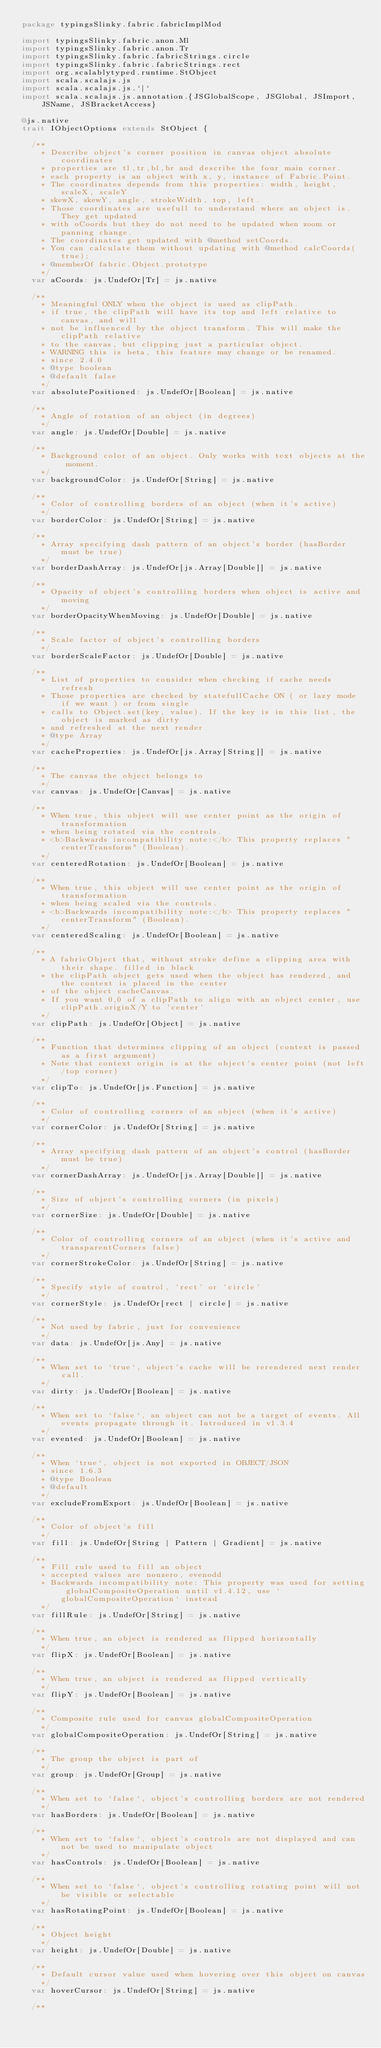Convert code to text. <code><loc_0><loc_0><loc_500><loc_500><_Scala_>package typingsSlinky.fabric.fabricImplMod

import typingsSlinky.fabric.anon.Ml
import typingsSlinky.fabric.anon.Tr
import typingsSlinky.fabric.fabricStrings.circle
import typingsSlinky.fabric.fabricStrings.rect
import org.scalablytyped.runtime.StObject
import scala.scalajs.js
import scala.scalajs.js.`|`
import scala.scalajs.js.annotation.{JSGlobalScope, JSGlobal, JSImport, JSName, JSBracketAccess}

@js.native
trait IObjectOptions extends StObject {
  
  /**
    * Describe object's corner position in canvas object absolute coordinates
    * properties are tl,tr,bl,br and describe the four main corner.
    * each property is an object with x, y, instance of Fabric.Point.
    * The coordinates depends from this properties: width, height, scaleX, scaleY
    * skewX, skewY, angle, strokeWidth, top, left.
    * Those coordinates are usefull to understand where an object is. They get updated
    * with oCoords but they do not need to be updated when zoom or panning change.
    * The coordinates get updated with @method setCoords.
    * You can calculate them without updating with @method calcCoords(true);
    * @memberOf fabric.Object.prototype
    */
  var aCoords: js.UndefOr[Tr] = js.native
  
  /**
    * Meaningful ONLY when the object is used as clipPath.
    * if true, the clipPath will have its top and left relative to canvas, and will
    * not be influenced by the object transform. This will make the clipPath relative
    * to the canvas, but clipping just a particular object.
    * WARNING this is beta, this feature may change or be renamed.
    * since 2.4.0
    * @type boolean
    * @default false
    */
  var absolutePositioned: js.UndefOr[Boolean] = js.native
  
  /**
    * Angle of rotation of an object (in degrees)
    */
  var angle: js.UndefOr[Double] = js.native
  
  /**
    * Background color of an object. Only works with text objects at the moment.
    */
  var backgroundColor: js.UndefOr[String] = js.native
  
  /**
    * Color of controlling borders of an object (when it's active)
    */
  var borderColor: js.UndefOr[String] = js.native
  
  /**
    * Array specifying dash pattern of an object's border (hasBorder must be true)
    */
  var borderDashArray: js.UndefOr[js.Array[Double]] = js.native
  
  /**
    * Opacity of object's controlling borders when object is active and moving
    */
  var borderOpacityWhenMoving: js.UndefOr[Double] = js.native
  
  /**
    * Scale factor of object's controlling borders
    */
  var borderScaleFactor: js.UndefOr[Double] = js.native
  
  /**
    * List of properties to consider when checking if cache needs refresh
    * Those properties are checked by statefullCache ON ( or lazy mode if we want ) or from single
    * calls to Object.set(key, value). If the key is in this list, the object is marked as dirty
    * and refreshed at the next render
    * @type Array
    */
  var cacheProperties: js.UndefOr[js.Array[String]] = js.native
  
  /**
    * The canvas the object belongs to
    */
  var canvas: js.UndefOr[Canvas] = js.native
  
  /**
    * When true, this object will use center point as the origin of transformation
    * when being rotated via the controls.
    * <b>Backwards incompatibility note:</b> This property replaces "centerTransform" (Boolean).
    */
  var centeredRotation: js.UndefOr[Boolean] = js.native
  
  /**
    * When true, this object will use center point as the origin of transformation
    * when being scaled via the controls.
    * <b>Backwards incompatibility note:</b> This property replaces "centerTransform" (Boolean).
    */
  var centeredScaling: js.UndefOr[Boolean] = js.native
  
  /**
    * A fabricObject that, without stroke define a clipping area with their shape. filled in black
    * the clipPath object gets used when the object has rendered, and the context is placed in the center
    * of the object cacheCanvas.
    * If you want 0,0 of a clipPath to align with an object center, use clipPath.originX/Y to 'center'
    */
  var clipPath: js.UndefOr[Object] = js.native
  
  /**
    * Function that determines clipping of an object (context is passed as a first argument)
    * Note that context origin is at the object's center point (not left/top corner)
    */
  var clipTo: js.UndefOr[js.Function] = js.native
  
  /**
    * Color of controlling corners of an object (when it's active)
    */
  var cornerColor: js.UndefOr[String] = js.native
  
  /**
    * Array specifying dash pattern of an object's control (hasBorder must be true)
    */
  var cornerDashArray: js.UndefOr[js.Array[Double]] = js.native
  
  /**
    * Size of object's controlling corners (in pixels)
    */
  var cornerSize: js.UndefOr[Double] = js.native
  
  /**
    * Color of controlling corners of an object (when it's active and transparentCorners false)
    */
  var cornerStrokeColor: js.UndefOr[String] = js.native
  
  /**
    * Specify style of control, 'rect' or 'circle'
    */
  var cornerStyle: js.UndefOr[rect | circle] = js.native
  
  /**
    * Not used by fabric, just for convenience
    */
  var data: js.UndefOr[js.Any] = js.native
  
  /**
    * When set to `true`, object's cache will be rerendered next render call.
    */
  var dirty: js.UndefOr[Boolean] = js.native
  
  /**
    * When set to `false`, an object can not be a target of events. All events propagate through it. Introduced in v1.3.4
    */
  var evented: js.UndefOr[Boolean] = js.native
  
  /**
    * When `true`, object is not exported in OBJECT/JSON
    * since 1.6.3
    * @type Boolean
    * @default
    */
  var excludeFromExport: js.UndefOr[Boolean] = js.native
  
  /**
    * Color of object's fill
    */
  var fill: js.UndefOr[String | Pattern | Gradient] = js.native
  
  /**
    * Fill rule used to fill an object
    * accepted values are nonzero, evenodd
    * Backwards incompatibility note: This property was used for setting globalCompositeOperation until v1.4.12, use `globalCompositeOperation` instead
    */
  var fillRule: js.UndefOr[String] = js.native
  
  /**
    * When true, an object is rendered as flipped horizontally
    */
  var flipX: js.UndefOr[Boolean] = js.native
  
  /**
    * When true, an object is rendered as flipped vertically
    */
  var flipY: js.UndefOr[Boolean] = js.native
  
  /**
    * Composite rule used for canvas globalCompositeOperation
    */
  var globalCompositeOperation: js.UndefOr[String] = js.native
  
  /**
    * The group the object is part of
    */
  var group: js.UndefOr[Group] = js.native
  
  /**
    * When set to `false`, object's controlling borders are not rendered
    */
  var hasBorders: js.UndefOr[Boolean] = js.native
  
  /**
    * When set to `false`, object's controls are not displayed and can not be used to manipulate object
    */
  var hasControls: js.UndefOr[Boolean] = js.native
  
  /**
    * When set to `false`, object's controlling rotating point will not be visible or selectable
    */
  var hasRotatingPoint: js.UndefOr[Boolean] = js.native
  
  /**
    * Object height
    */
  var height: js.UndefOr[Double] = js.native
  
  /**
    * Default cursor value used when hovering over this object on canvas
    */
  var hoverCursor: js.UndefOr[String] = js.native
  
  /**</code> 